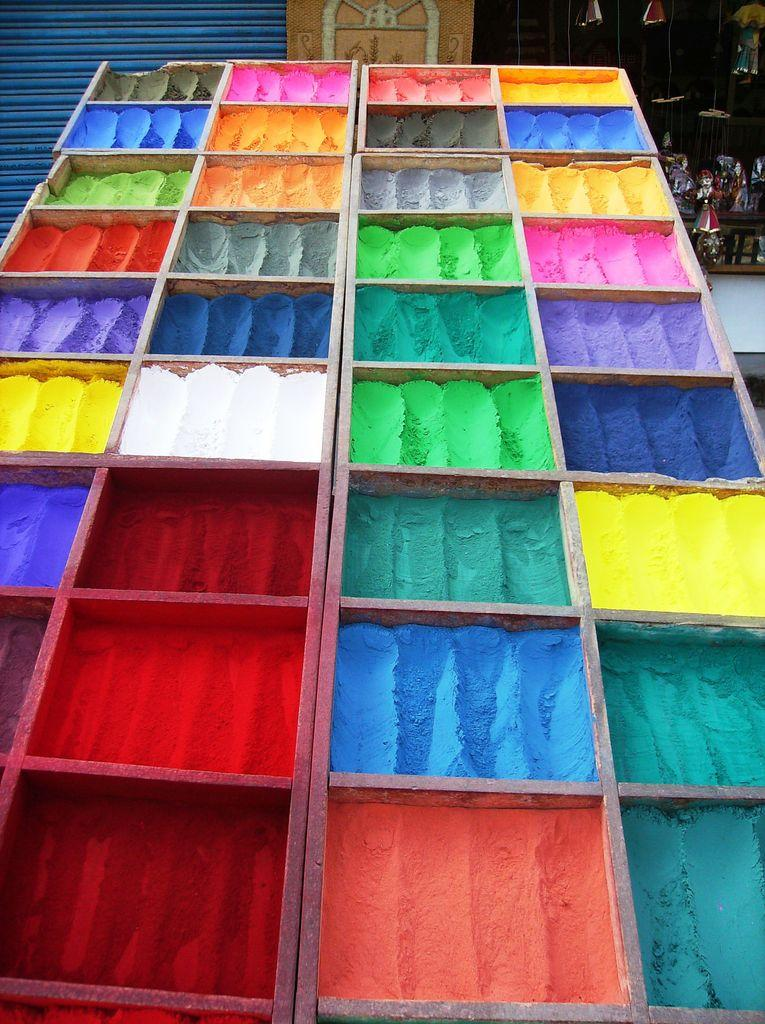What type of objects are present in the image? There are wooden boxes in the image. What is unique about the wooden boxes? The wooden boxes have colors on them. What can be seen in the background of the image? There is a shutter in the background of the image. What type of tree is growing on the moon in the image? There is no tree or moon present in the image; it only features wooden boxes with colors and a shutter in the background. 